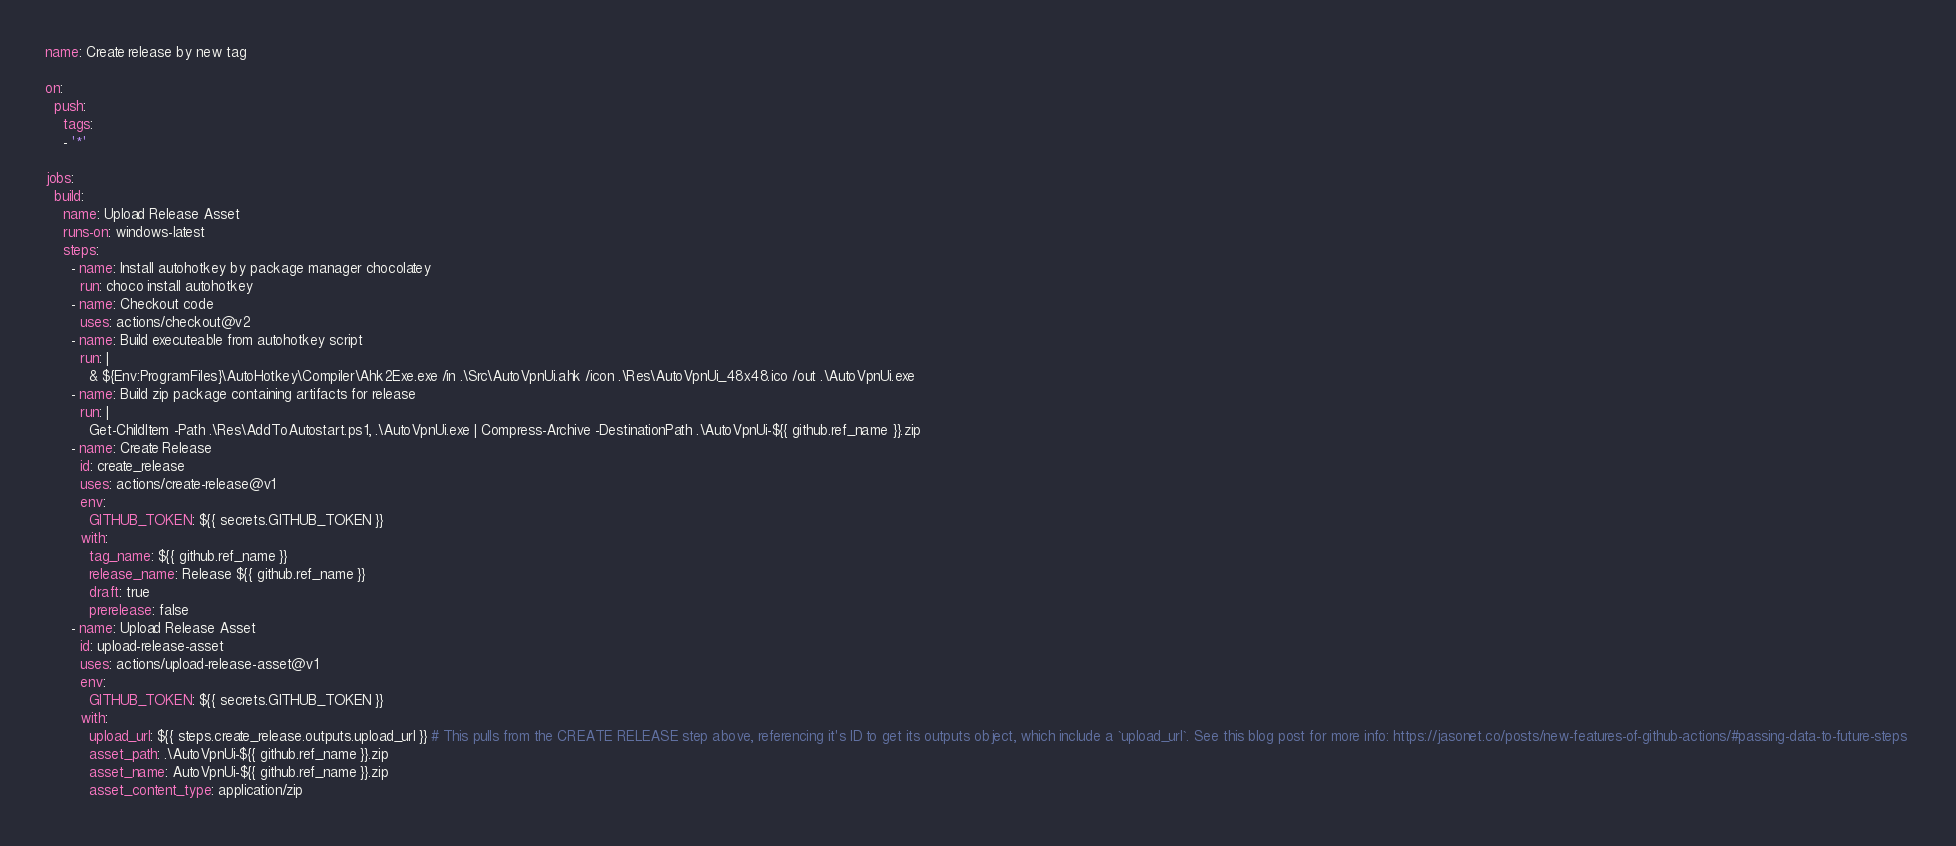Convert code to text. <code><loc_0><loc_0><loc_500><loc_500><_YAML_>
name: Create release by new tag

on:
  push:
    tags:
    - '*'

jobs:
  build:
    name: Upload Release Asset
    runs-on: windows-latest
    steps:
      - name: Install autohotkey by package manager chocolatey
        run: choco install autohotkey
      - name: Checkout code
        uses: actions/checkout@v2
      - name: Build executeable from autohotkey script
        run: |
          & ${Env:ProgramFiles}\AutoHotkey\Compiler\Ahk2Exe.exe /in .\Src\AutoVpnUi.ahk /icon .\Res\AutoVpnUi_48x48.ico /out .\AutoVpnUi.exe
      - name: Build zip package containing artifacts for release
        run: |
          Get-ChildItem -Path .\Res\AddToAutostart.ps1, .\AutoVpnUi.exe | Compress-Archive -DestinationPath .\AutoVpnUi-${{ github.ref_name }}.zip
      - name: Create Release
        id: create_release
        uses: actions/create-release@v1
        env:
          GITHUB_TOKEN: ${{ secrets.GITHUB_TOKEN }}
        with:
          tag_name: ${{ github.ref_name }}
          release_name: Release ${{ github.ref_name }}
          draft: true
          prerelease: false
      - name: Upload Release Asset
        id: upload-release-asset 
        uses: actions/upload-release-asset@v1
        env:
          GITHUB_TOKEN: ${{ secrets.GITHUB_TOKEN }}
        with:
          upload_url: ${{ steps.create_release.outputs.upload_url }} # This pulls from the CREATE RELEASE step above, referencing it's ID to get its outputs object, which include a `upload_url`. See this blog post for more info: https://jasonet.co/posts/new-features-of-github-actions/#passing-data-to-future-steps 
          asset_path: .\AutoVpnUi-${{ github.ref_name }}.zip
          asset_name: AutoVpnUi-${{ github.ref_name }}.zip
          asset_content_type: application/zip
</code> 